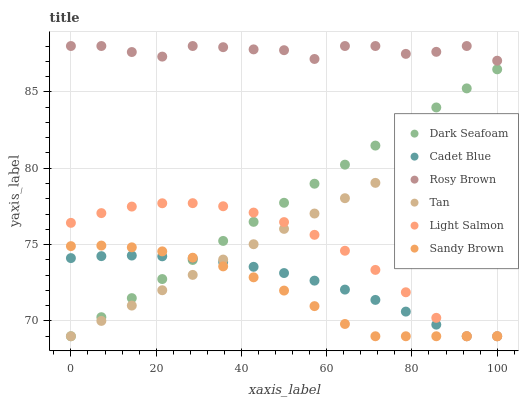Does Sandy Brown have the minimum area under the curve?
Answer yes or no. Yes. Does Rosy Brown have the maximum area under the curve?
Answer yes or no. Yes. Does Cadet Blue have the minimum area under the curve?
Answer yes or no. No. Does Cadet Blue have the maximum area under the curve?
Answer yes or no. No. Is Dark Seafoam the smoothest?
Answer yes or no. Yes. Is Rosy Brown the roughest?
Answer yes or no. Yes. Is Cadet Blue the smoothest?
Answer yes or no. No. Is Cadet Blue the roughest?
Answer yes or no. No. Does Light Salmon have the lowest value?
Answer yes or no. Yes. Does Rosy Brown have the lowest value?
Answer yes or no. No. Does Rosy Brown have the highest value?
Answer yes or no. Yes. Does Cadet Blue have the highest value?
Answer yes or no. No. Is Dark Seafoam less than Rosy Brown?
Answer yes or no. Yes. Is Rosy Brown greater than Tan?
Answer yes or no. Yes. Does Light Salmon intersect Dark Seafoam?
Answer yes or no. Yes. Is Light Salmon less than Dark Seafoam?
Answer yes or no. No. Is Light Salmon greater than Dark Seafoam?
Answer yes or no. No. Does Dark Seafoam intersect Rosy Brown?
Answer yes or no. No. 